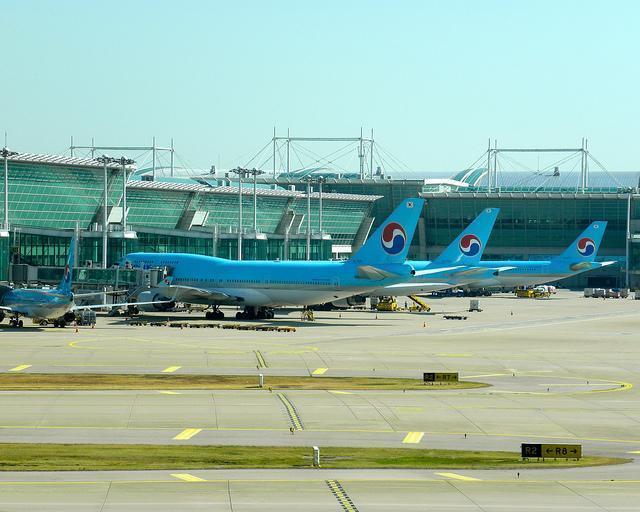The symbol on the planes looks like what logo?
Choose the right answer from the provided options to respond to the question.
Options: Pepsi, mcdonald's, starbucks, nbc. Pepsi. 